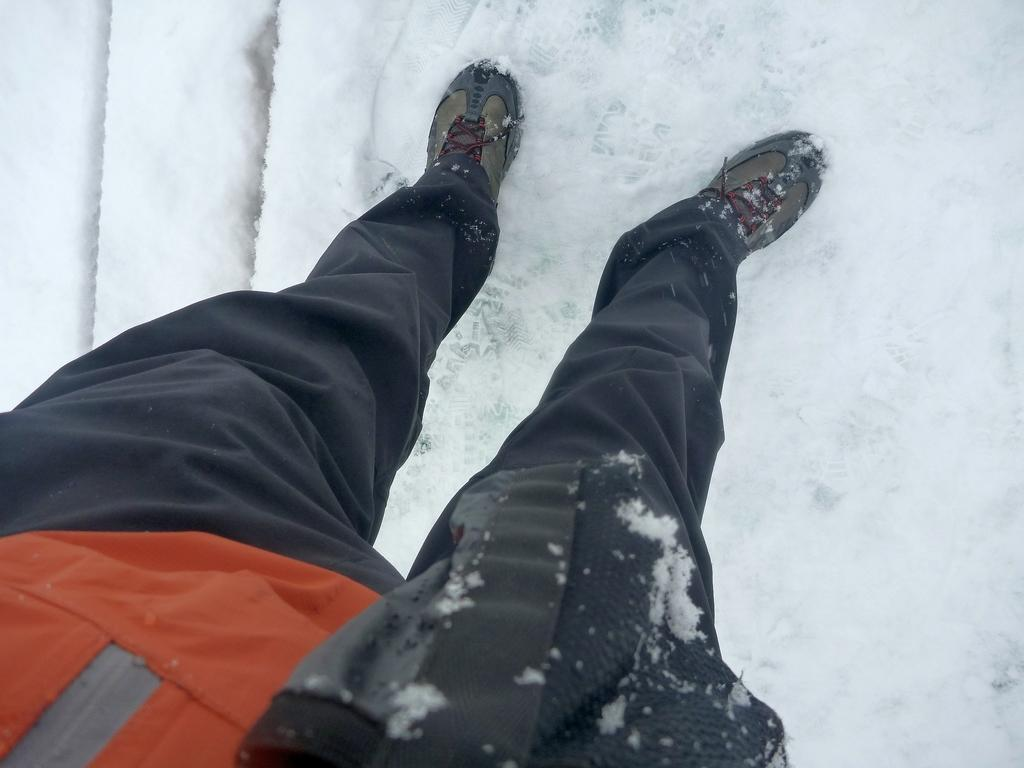Who or what is the main subject in the image? There is a person in the image. What is the person standing on? The person is standing on snow. What type of footwear is the person wearing? The person is wearing shoes. How many babies are crawling on the person's shoes in the image? There are no babies present in the image, and therefore no babies crawling on the person's shoes. 